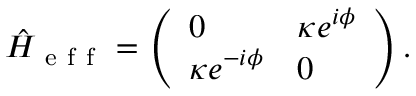Convert formula to latex. <formula><loc_0><loc_0><loc_500><loc_500>\hat { H } _ { e f f } = \left ( \begin{array} { l l } { 0 } & { \kappa e ^ { i \phi } } \\ { \kappa e ^ { - i \phi } } & { 0 } \end{array} \right ) .</formula> 